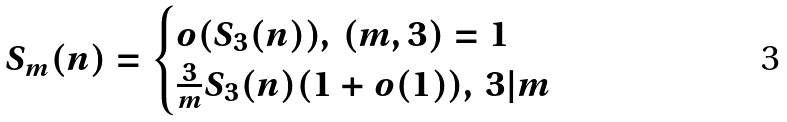<formula> <loc_0><loc_0><loc_500><loc_500>S _ { m } ( n ) = \begin{cases} o ( S _ { 3 } ( n ) ) , \, ( m , 3 ) = 1 \\ \frac { 3 } { m } S _ { 3 } ( n ) ( 1 + o ( 1 ) ) , \, 3 | m \end{cases}</formula> 